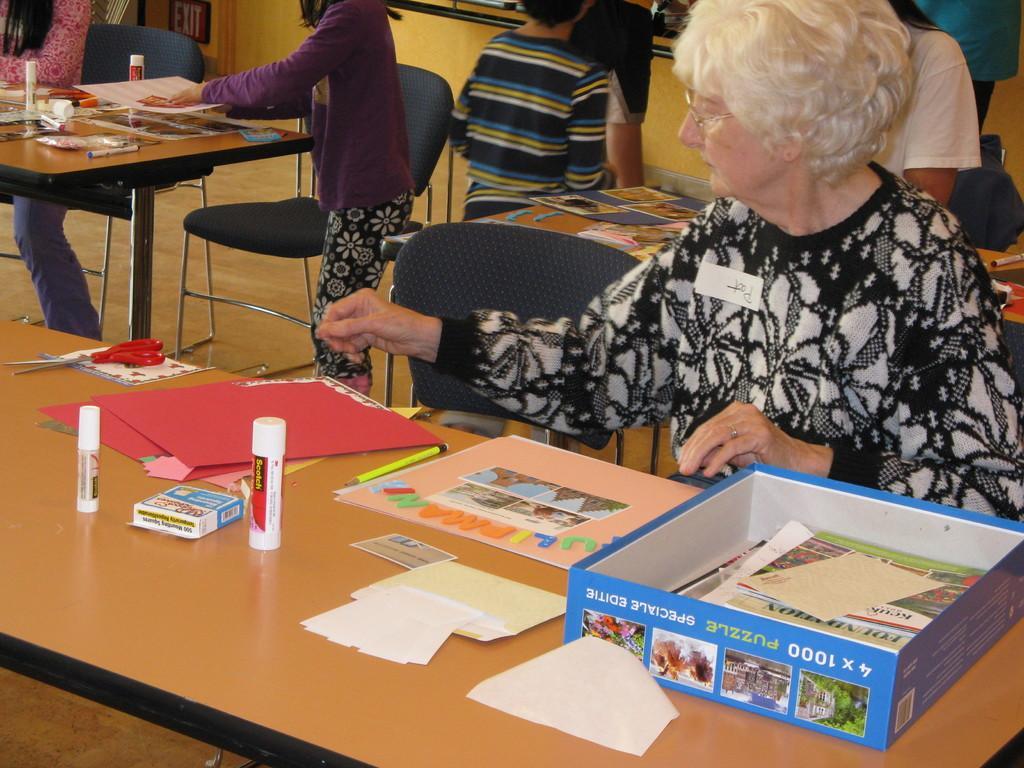Please provide a concise description of this image. In this image there are group of people in the room. In front there is a woman sitting on the chair. On the table there are scissors,glue,craft papers and some papers in the cardboard box. At the background there are few people walking on the floor. 